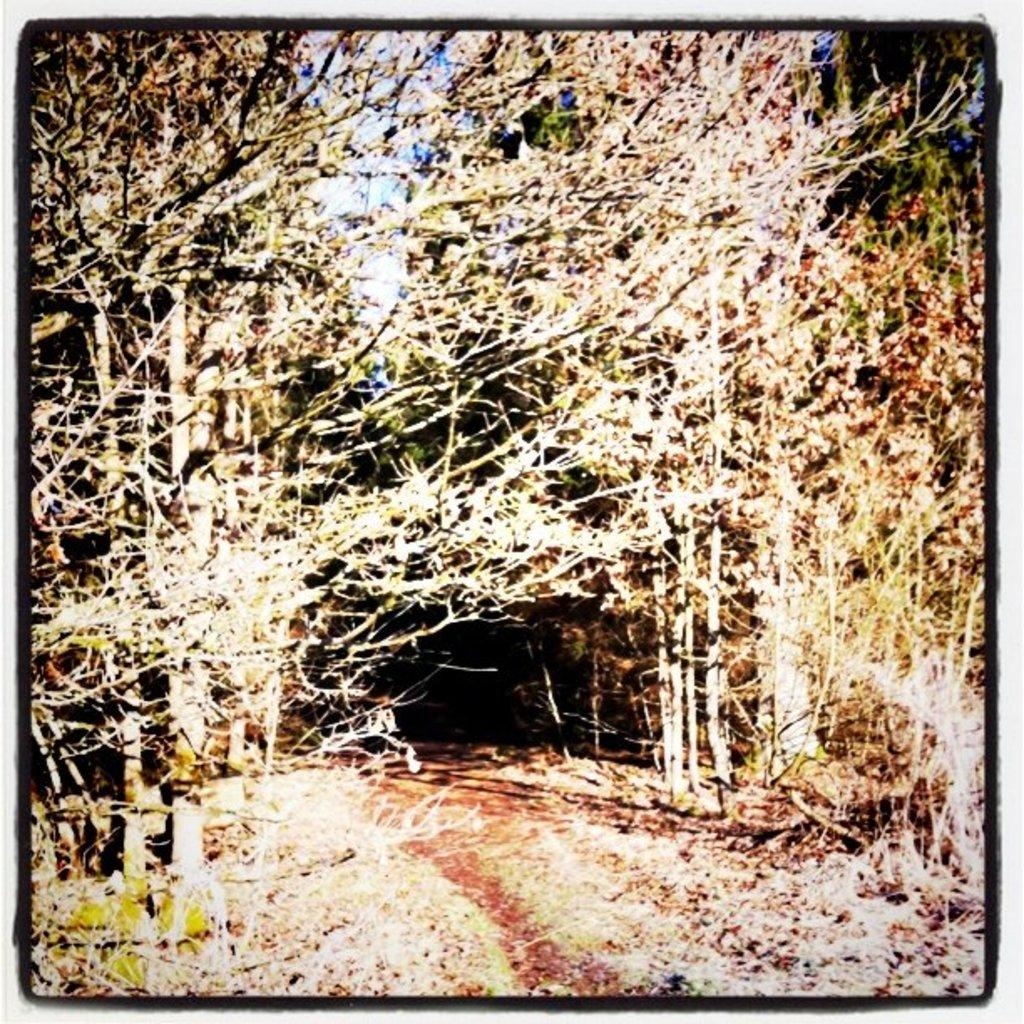What type of location is depicted in the edited picture? The image is an edited picture of a forest. What can be found in a forest? There are trees in the image. Is there a way to navigate through the forest in the image? Yes, there is a path in the image. What can be seen above the trees in the image? The sky is visible in the image. What type of match is being played on the wrist in the image? There is no match or wrist present in the image; it is a picture of a forest with trees, a path, and a visible sky. 